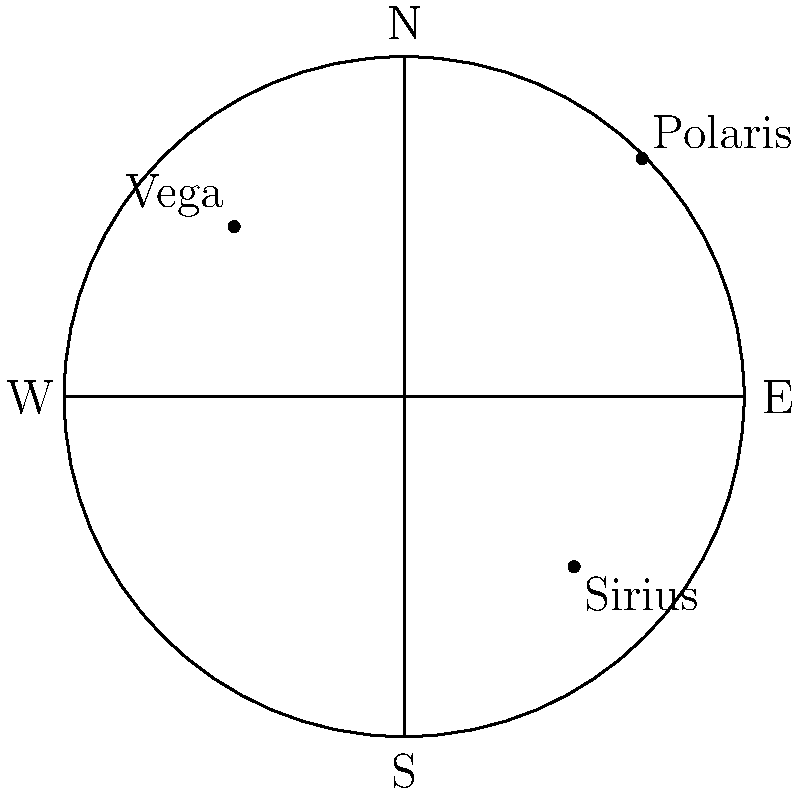In the night sky, Polaris is often used as a guiding star for navigation. Based on the celestial map provided, which cardinal direction would you face if you were to walk directly towards Polaris? To determine the cardinal direction when facing Polaris, we need to follow these steps:

1. Recall that Polaris, also known as the North Star, is always located very close to the celestial north pole.

2. In the provided celestial map, we can see that Polaris is positioned in the upper right quadrant.

3. The cardinal directions are clearly marked on the map:
   - North (N) is at the top
   - South (S) is at the bottom
   - East (E) is to the right
   - West (W) is to the left

4. Observe that Polaris is closest to the "N" label on the map.

5. This aligns with the fact that Polaris is used to find true north in celestial navigation.

6. Therefore, if you were to walk directly towards Polaris, you would be facing North.

This traditional method of navigation using the stars has been used for centuries and remains a reliable technique, even in our modern age.
Answer: North 